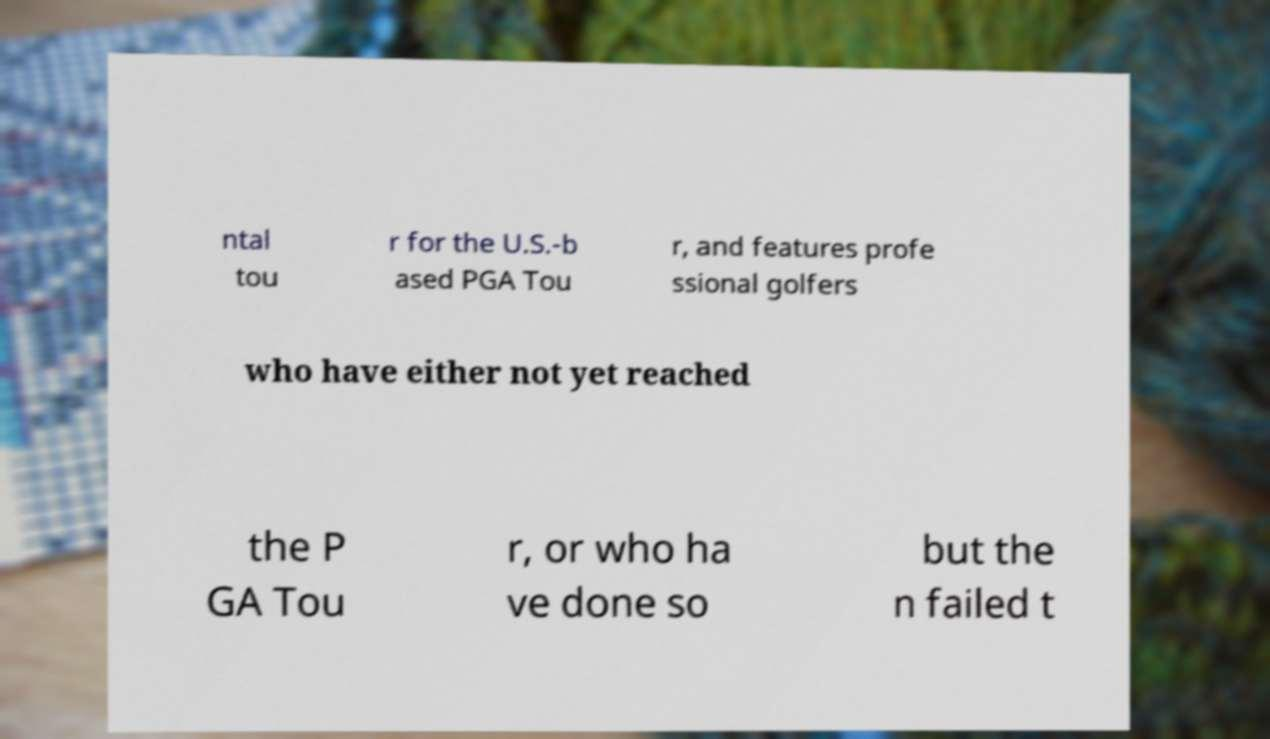For documentation purposes, I need the text within this image transcribed. Could you provide that? ntal tou r for the U.S.-b ased PGA Tou r, and features profe ssional golfers who have either not yet reached the P GA Tou r, or who ha ve done so but the n failed t 